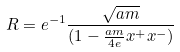Convert formula to latex. <formula><loc_0><loc_0><loc_500><loc_500>R = e ^ { - 1 } \frac { \sqrt { a m } } { ( 1 - \frac { a m } { 4 e } x ^ { + } x ^ { - } ) }</formula> 